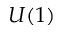<formula> <loc_0><loc_0><loc_500><loc_500>U ( 1 )</formula> 